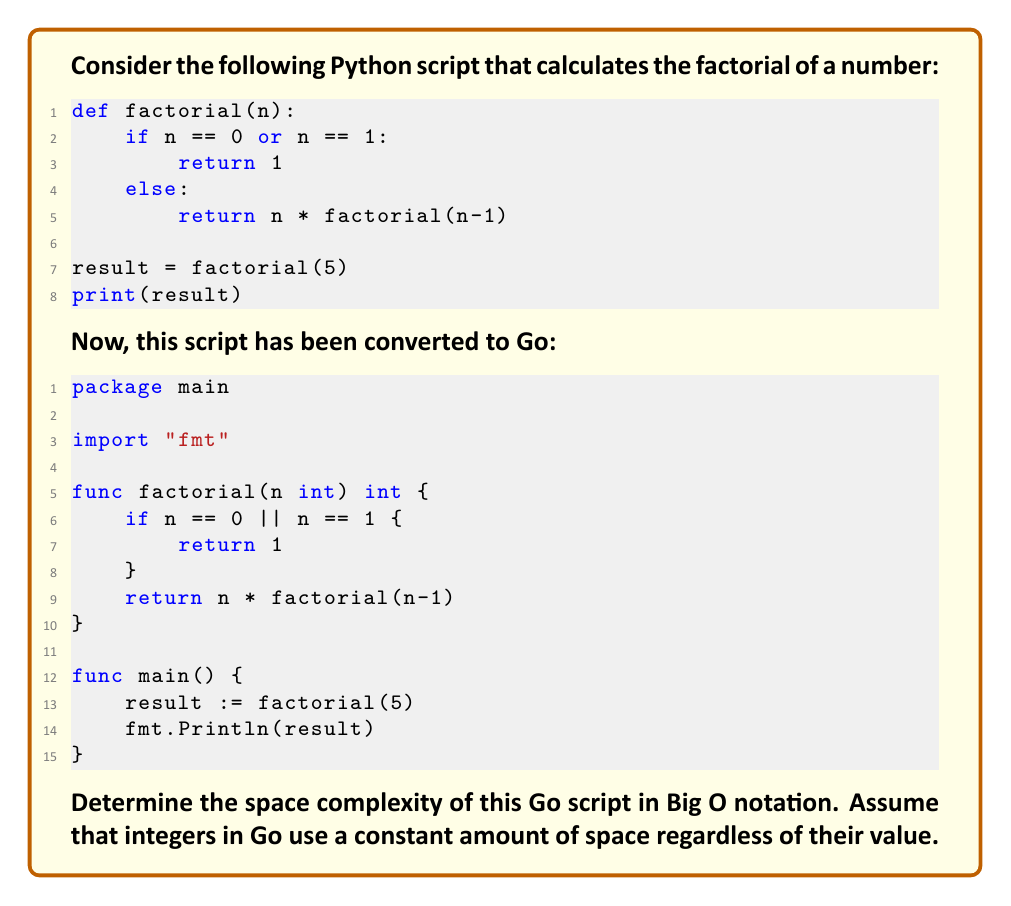Teach me how to tackle this problem. To determine the space complexity of the Go script, we need to analyze the memory usage of the factorial function:

1. The function is recursive, which means it creates a new stack frame for each recursive call.

2. Each stack frame contains:
   - The parameter `n` (constant space)
   - The return address (constant space)
   - Any local variables (none in this case)

3. The maximum depth of the recursion is equal to the input `n`.

4. Therefore, the total space used by the recursive calls is proportional to `n`.

5. In the `main` function, we have a single integer variable `result`, which uses constant space.

6. The space complexity is dominated by the recursive calls in the factorial function.

7. Hence, the overall space complexity is $O(n)$, where $n$ is the input to the factorial function.

It's worth noting that while the space complexity is the same for both the Python and Go versions, Go's implementation might be more memory-efficient due to its static typing and lack of additional overheads present in Python's dynamic typing system.
Answer: $O(n)$ 